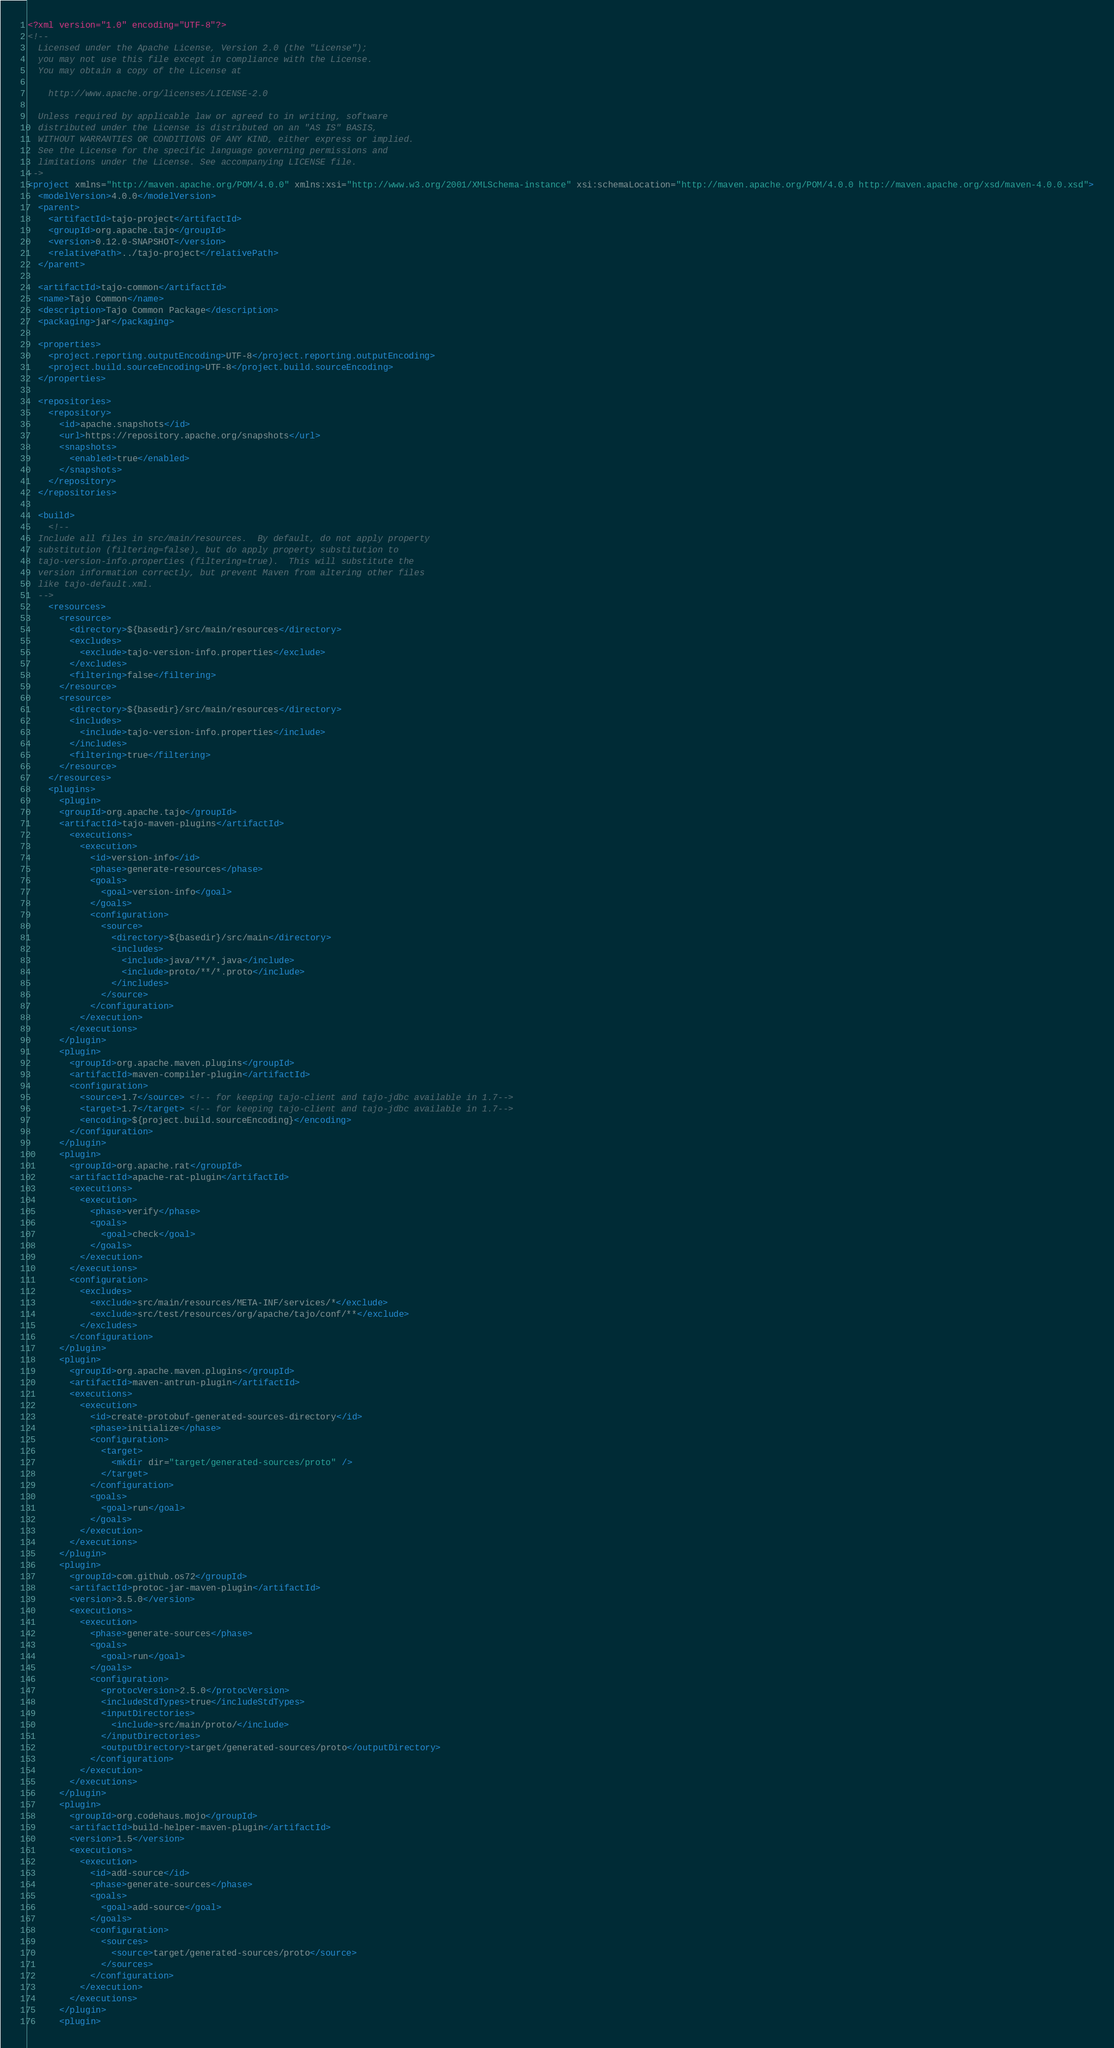Convert code to text. <code><loc_0><loc_0><loc_500><loc_500><_XML_><?xml version="1.0" encoding="UTF-8"?>
<!--
  Licensed under the Apache License, Version 2.0 (the "License");
  you may not use this file except in compliance with the License.
  You may obtain a copy of the License at

    http://www.apache.org/licenses/LICENSE-2.0

  Unless required by applicable law or agreed to in writing, software
  distributed under the License is distributed on an "AS IS" BASIS,
  WITHOUT WARRANTIES OR CONDITIONS OF ANY KIND, either express or implied.
  See the License for the specific language governing permissions and
  limitations under the License. See accompanying LICENSE file.
-->
<project xmlns="http://maven.apache.org/POM/4.0.0" xmlns:xsi="http://www.w3.org/2001/XMLSchema-instance" xsi:schemaLocation="http://maven.apache.org/POM/4.0.0 http://maven.apache.org/xsd/maven-4.0.0.xsd">
  <modelVersion>4.0.0</modelVersion>
  <parent>
    <artifactId>tajo-project</artifactId>
    <groupId>org.apache.tajo</groupId>
    <version>0.12.0-SNAPSHOT</version>
    <relativePath>../tajo-project</relativePath>
  </parent>

  <artifactId>tajo-common</artifactId>
  <name>Tajo Common</name>
  <description>Tajo Common Package</description>
  <packaging>jar</packaging>

  <properties>
    <project.reporting.outputEncoding>UTF-8</project.reporting.outputEncoding>
    <project.build.sourceEncoding>UTF-8</project.build.sourceEncoding>
  </properties>

  <repositories>
    <repository>
      <id>apache.snapshots</id>
      <url>https://repository.apache.org/snapshots</url>
      <snapshots>
        <enabled>true</enabled>
      </snapshots>
    </repository>
  </repositories>

  <build>
    <!--
  Include all files in src/main/resources.  By default, do not apply property
  substitution (filtering=false), but do apply property substitution to
  tajo-version-info.properties (filtering=true).  This will substitute the
  version information correctly, but prevent Maven from altering other files
  like tajo-default.xml.
  -->
    <resources>
      <resource>
        <directory>${basedir}/src/main/resources</directory>
        <excludes>
          <exclude>tajo-version-info.properties</exclude>
        </excludes>
        <filtering>false</filtering>
      </resource>
      <resource>
        <directory>${basedir}/src/main/resources</directory>
        <includes>
          <include>tajo-version-info.properties</include>
        </includes>
        <filtering>true</filtering>
      </resource>
    </resources>
    <plugins>
      <plugin>
      <groupId>org.apache.tajo</groupId>
      <artifactId>tajo-maven-plugins</artifactId>
        <executions>
          <execution>
            <id>version-info</id>
            <phase>generate-resources</phase>
            <goals>
              <goal>version-info</goal>
            </goals>
            <configuration>
              <source>
                <directory>${basedir}/src/main</directory>
                <includes>
                  <include>java/**/*.java</include>
                  <include>proto/**/*.proto</include>
                </includes>
              </source>
            </configuration>
          </execution>
        </executions>
      </plugin>
      <plugin>
        <groupId>org.apache.maven.plugins</groupId>
        <artifactId>maven-compiler-plugin</artifactId>
        <configuration>
          <source>1.7</source> <!-- for keeping tajo-client and tajo-jdbc available in 1.7-->
          <target>1.7</target> <!-- for keeping tajo-client and tajo-jdbc available in 1.7-->
          <encoding>${project.build.sourceEncoding}</encoding>
        </configuration>
      </plugin>
      <plugin>
        <groupId>org.apache.rat</groupId>
        <artifactId>apache-rat-plugin</artifactId>
        <executions>
          <execution>
            <phase>verify</phase>
            <goals>
              <goal>check</goal>
            </goals>
          </execution>
        </executions>
        <configuration>
          <excludes>
          	<exclude>src/main/resources/META-INF/services/*</exclude>
            <exclude>src/test/resources/org/apache/tajo/conf/**</exclude>
          </excludes>
        </configuration>
      </plugin>
      <plugin>
        <groupId>org.apache.maven.plugins</groupId>
        <artifactId>maven-antrun-plugin</artifactId>
        <executions>
          <execution>
            <id>create-protobuf-generated-sources-directory</id>
            <phase>initialize</phase>
            <configuration>
              <target>
                <mkdir dir="target/generated-sources/proto" />
              </target>
            </configuration>
            <goals>
              <goal>run</goal>
            </goals>
          </execution>
        </executions>
      </plugin>
      <plugin>
        <groupId>com.github.os72</groupId>
        <artifactId>protoc-jar-maven-plugin</artifactId>
        <version>3.5.0</version>
        <executions>
          <execution>
            <phase>generate-sources</phase>
            <goals>
              <goal>run</goal>
            </goals>
            <configuration>
              <protocVersion>2.5.0</protocVersion>
              <includeStdTypes>true</includeStdTypes>
              <inputDirectories>
                <include>src/main/proto/</include>
              </inputDirectories>
              <outputDirectory>target/generated-sources/proto</outputDirectory>
            </configuration>
          </execution>
        </executions>
      </plugin>
      <plugin>
        <groupId>org.codehaus.mojo</groupId>
        <artifactId>build-helper-maven-plugin</artifactId>
        <version>1.5</version>
        <executions>
          <execution>
            <id>add-source</id>
            <phase>generate-sources</phase>
            <goals>
              <goal>add-source</goal>
            </goals>
            <configuration>
              <sources>
                <source>target/generated-sources/proto</source>
              </sources>
            </configuration>
          </execution>
        </executions>
      </plugin>
      <plugin></code> 